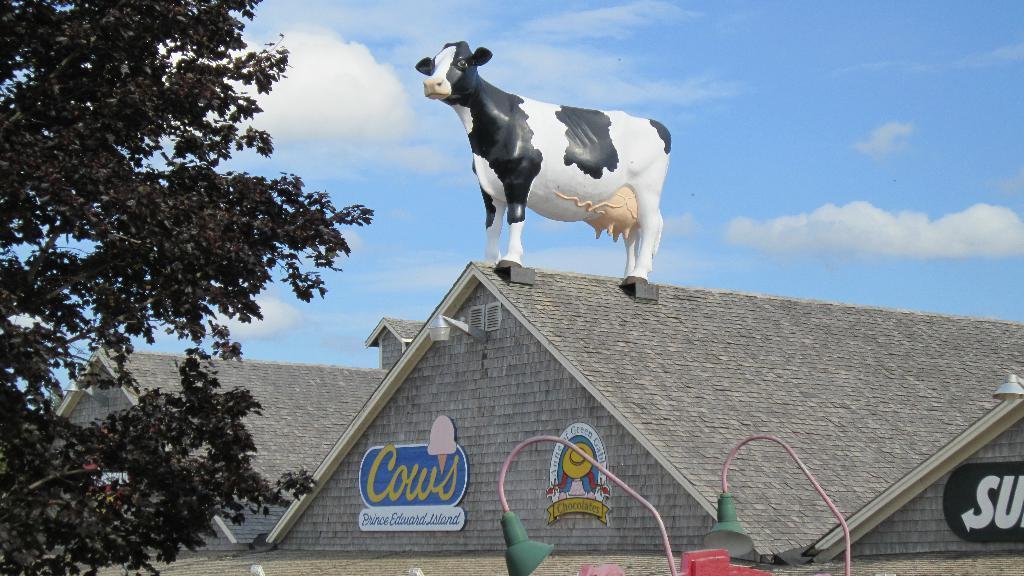How would you summarize this image in a sentence or two? In this image we can see that there is a roof in the middle. Above the roof there is a statue of a cow. To the wall there are boards. On the left side there is a tree. At the top there is the sky. At the bottom there are lights. On the right side bottom there is some text. 